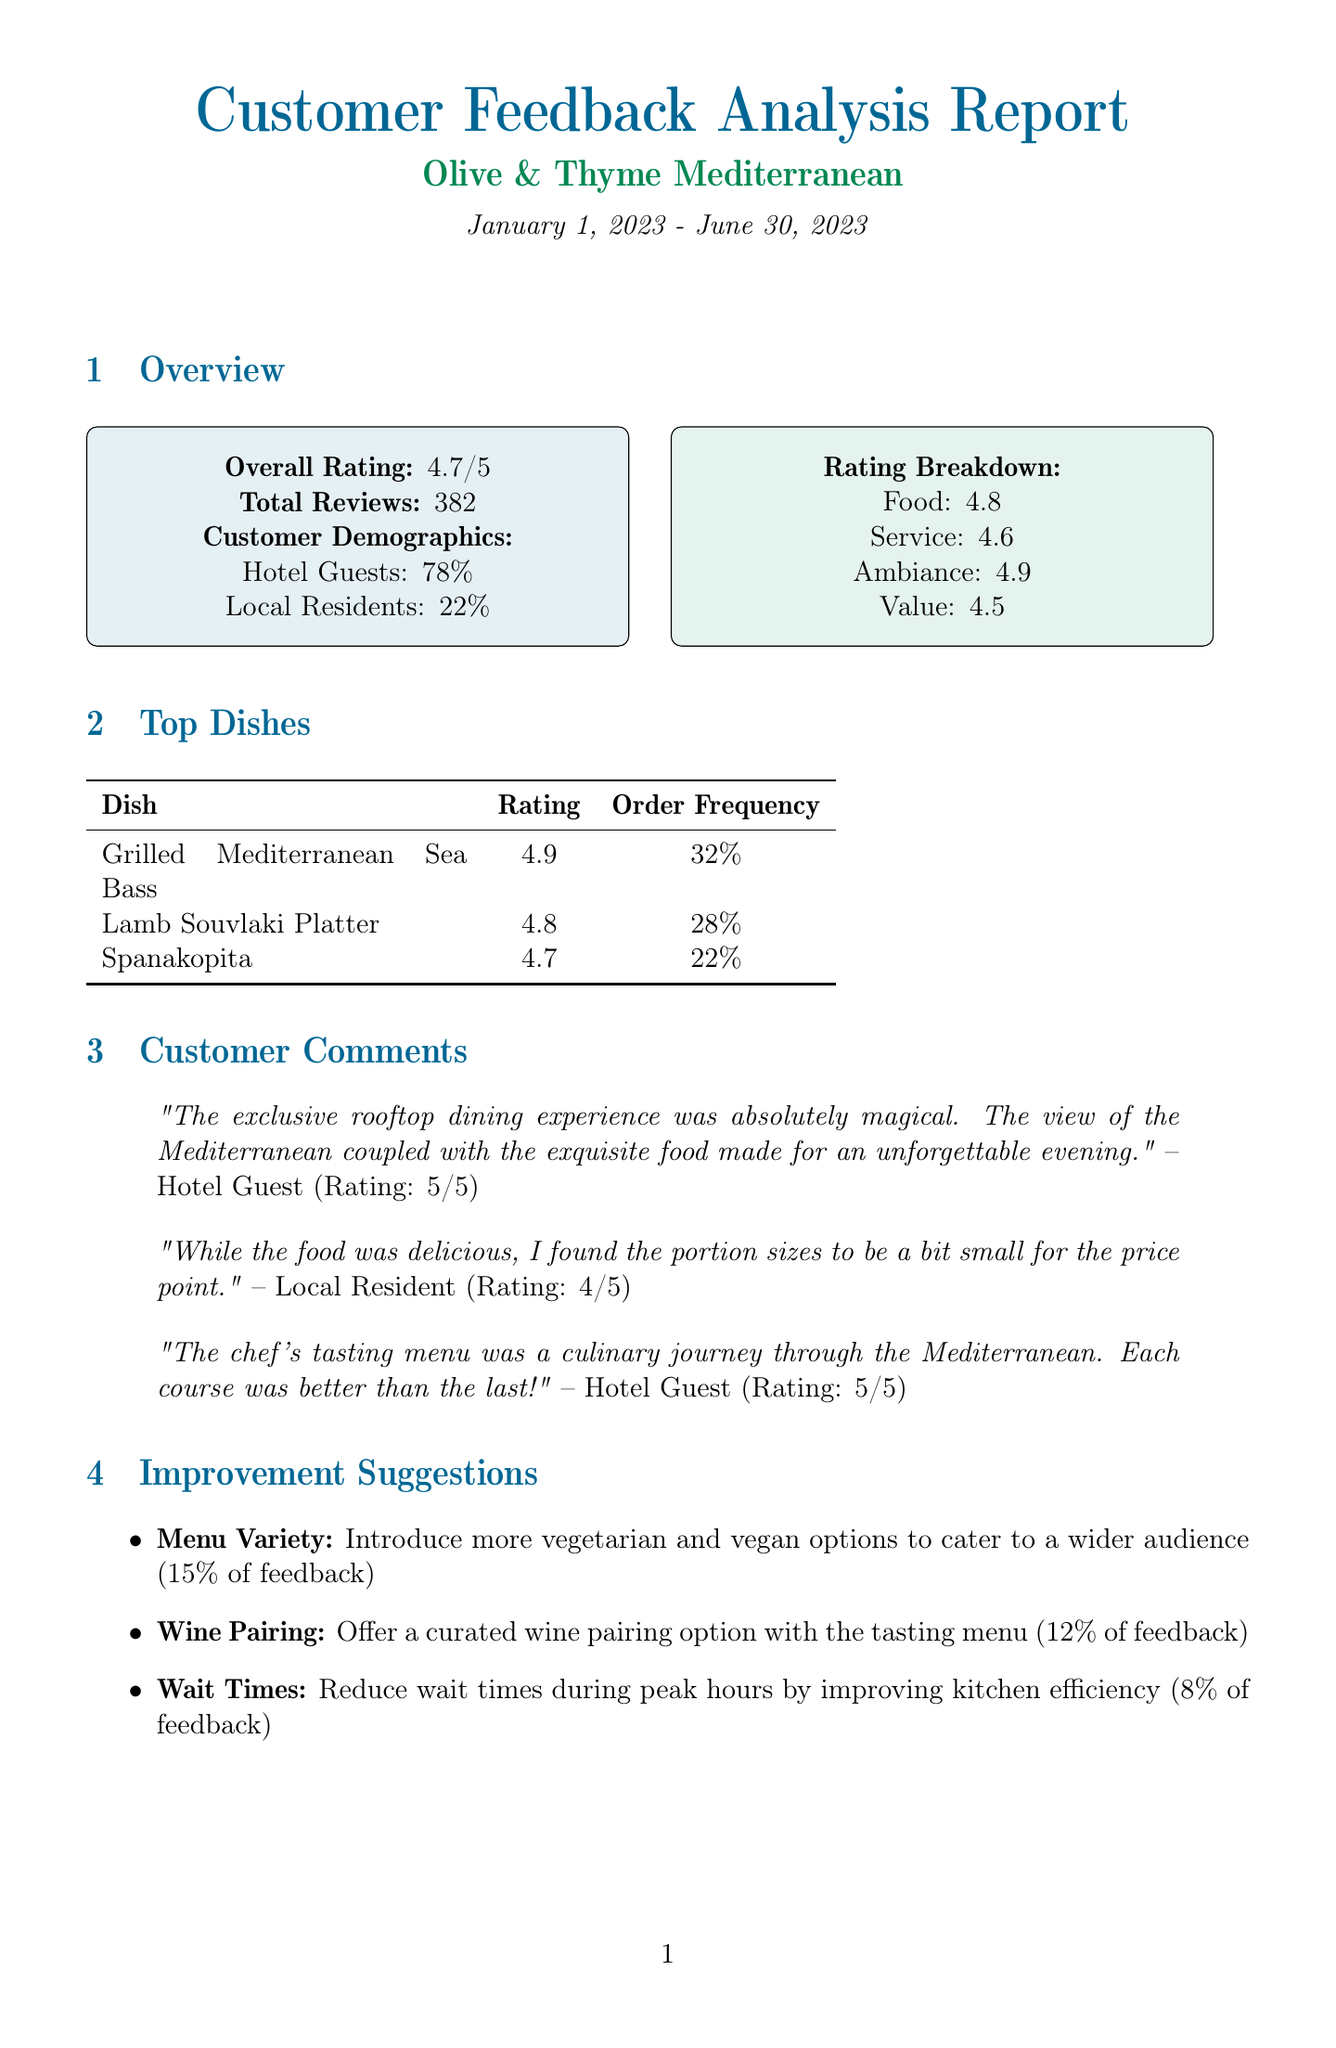What is the overall rating? The overall rating is a summary score indicating customer satisfaction for the period, which is 4.7.
Answer: 4.7 What percentage of customers are hotel guests? The customer demographics show that 78% of the reviews came from hotel guests.
Answer: 78% What dish has the highest rating? The top dish with the highest rating is the Grilled Mediterranean Sea Bass, which has a rating of 4.9.
Answer: Grilled Mediterranean Sea Bass What improvement suggestion was mentioned with the highest frequency? The improvement suggestion with the highest frequency is to introduce more vegetarian and vegan options, mentioned in 15% of the feedback.
Answer: Menu Variety How many exclusive dining experiences are listed? The report lists three exclusive dining experiences offered by the restaurant.
Answer: 3 What is the rating of the Sunset Rooftop Dinner? The Sunset Rooftop Dinner is rated as 4.9, indicating a high satisfaction level among customers.
Answer: 4.9 Which competitor offers lower overall ratings than Olive & Thyme? Santorini Blue and Mykonos Taverna both have lower overall ratings compared to Olive & Thyme.
Answer: Santorini Blue, Mykonos Taverna What area was suggested for reducing customer wait times? The suggestion for improvement clearly specifies that reducing wait times during peak hours is an area of concern.
Answer: Wait Times What action item is related to staff training? Staff training is mentioned in the action item to improve service efficiency during peak hours.
Answer: Conduct staff training 